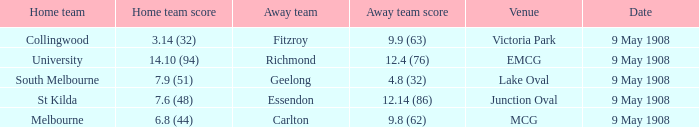What is the score for the away team at lake oval? 4.8 (32). 